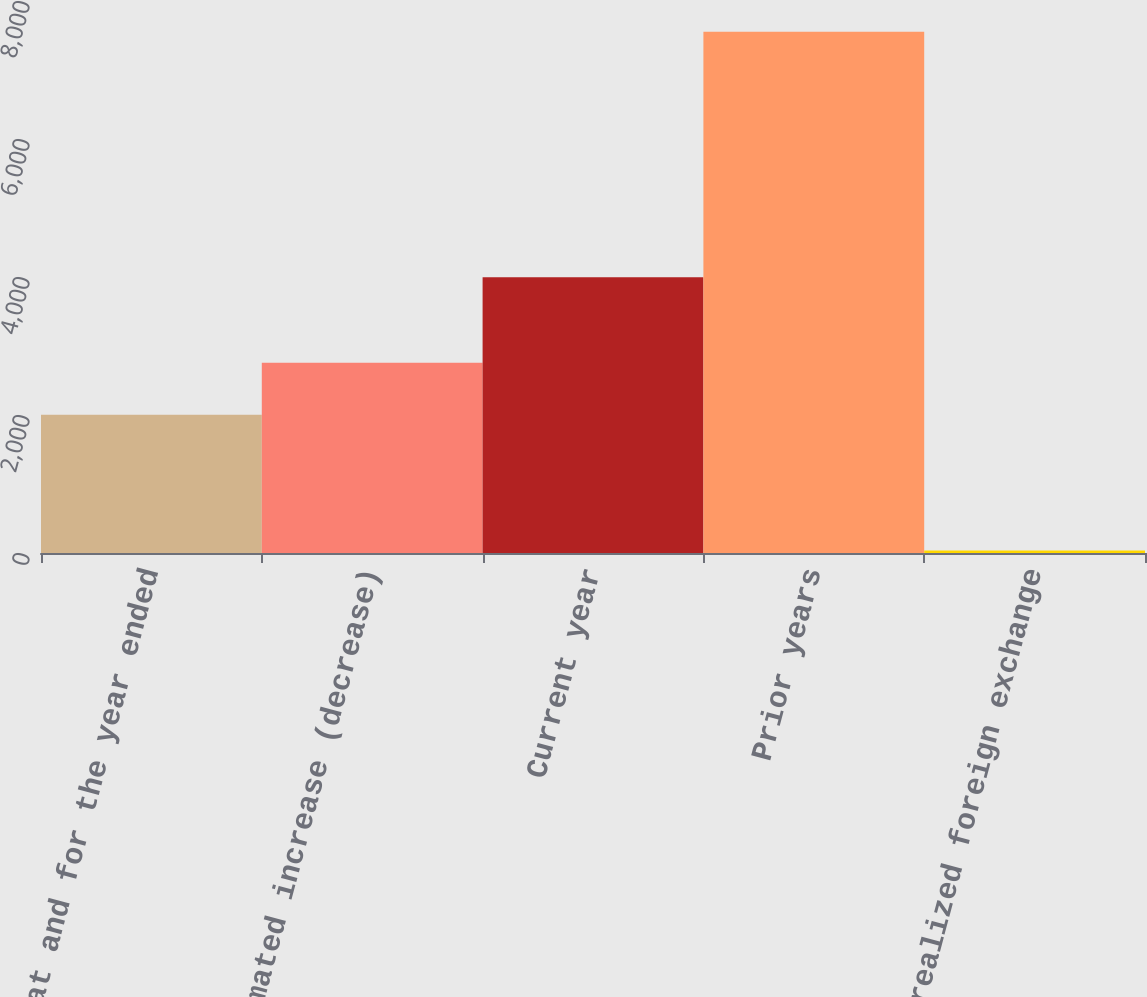Convert chart. <chart><loc_0><loc_0><loc_500><loc_500><bar_chart><fcel>(at and for the year ended<fcel>Estimated increase (decrease)<fcel>Current year<fcel>Prior years<fcel>Unrealized foreign exchange<nl><fcel>2004<fcel>2755.8<fcel>3998<fcel>7553<fcel>35<nl></chart> 